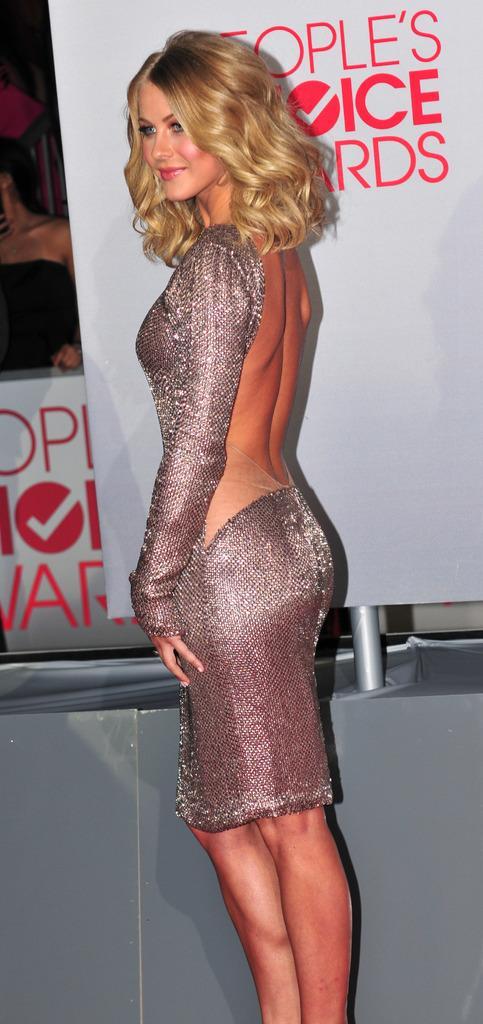Can you describe this image briefly? There is a lady standing. In the back there is a banner with a pole. Behind that there is another banner. 